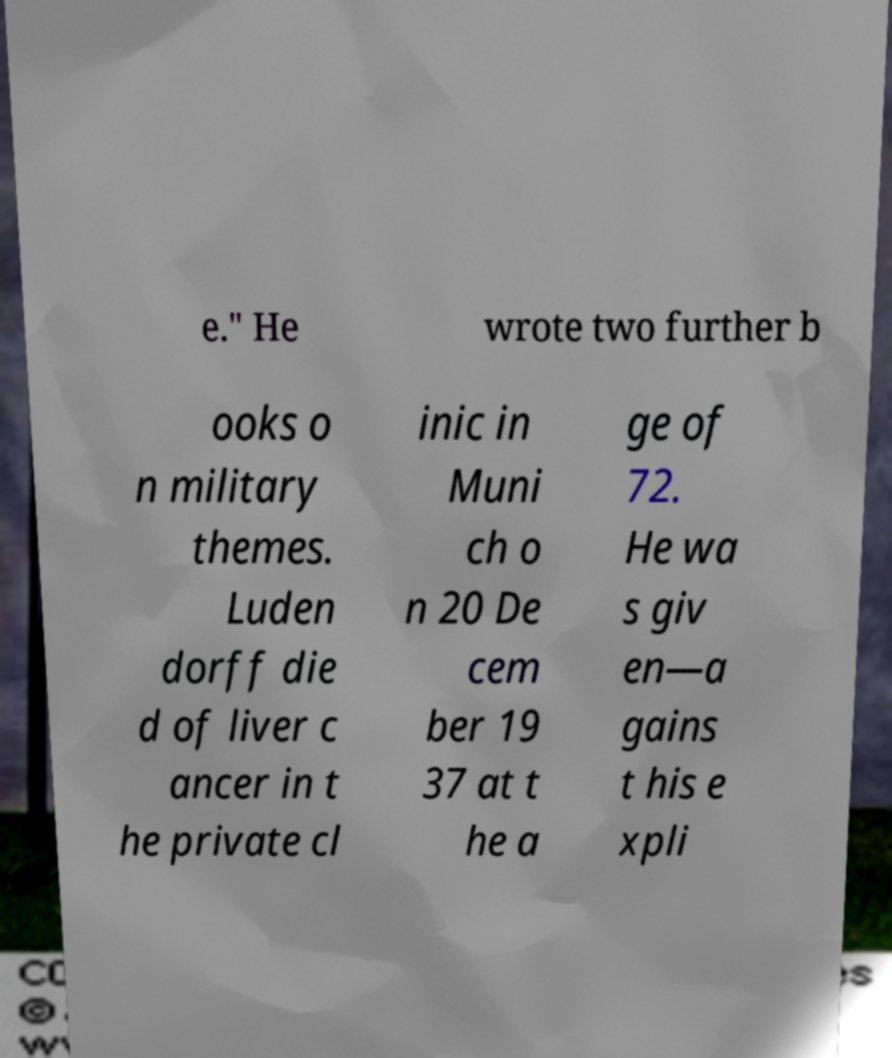What messages or text are displayed in this image? I need them in a readable, typed format. e." He wrote two further b ooks o n military themes. Luden dorff die d of liver c ancer in t he private cl inic in Muni ch o n 20 De cem ber 19 37 at t he a ge of 72. He wa s giv en—a gains t his e xpli 